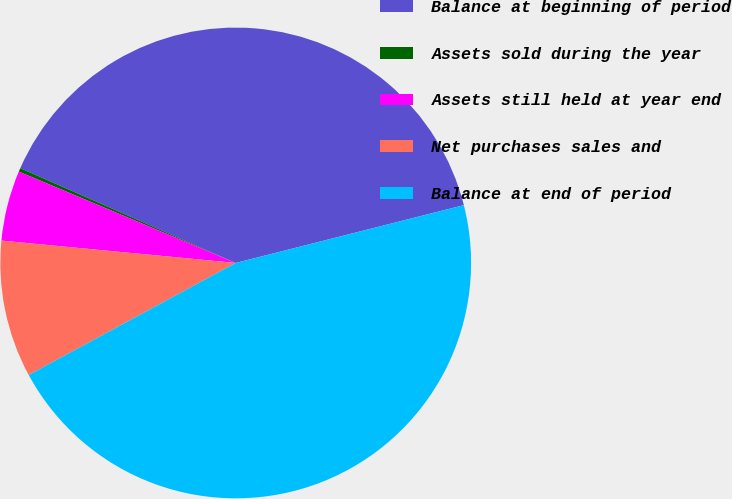<chart> <loc_0><loc_0><loc_500><loc_500><pie_chart><fcel>Balance at beginning of period<fcel>Assets sold during the year<fcel>Assets still held at year end<fcel>Net purchases sales and<fcel>Balance at end of period<nl><fcel>39.45%<fcel>0.25%<fcel>4.83%<fcel>9.41%<fcel>46.05%<nl></chart> 